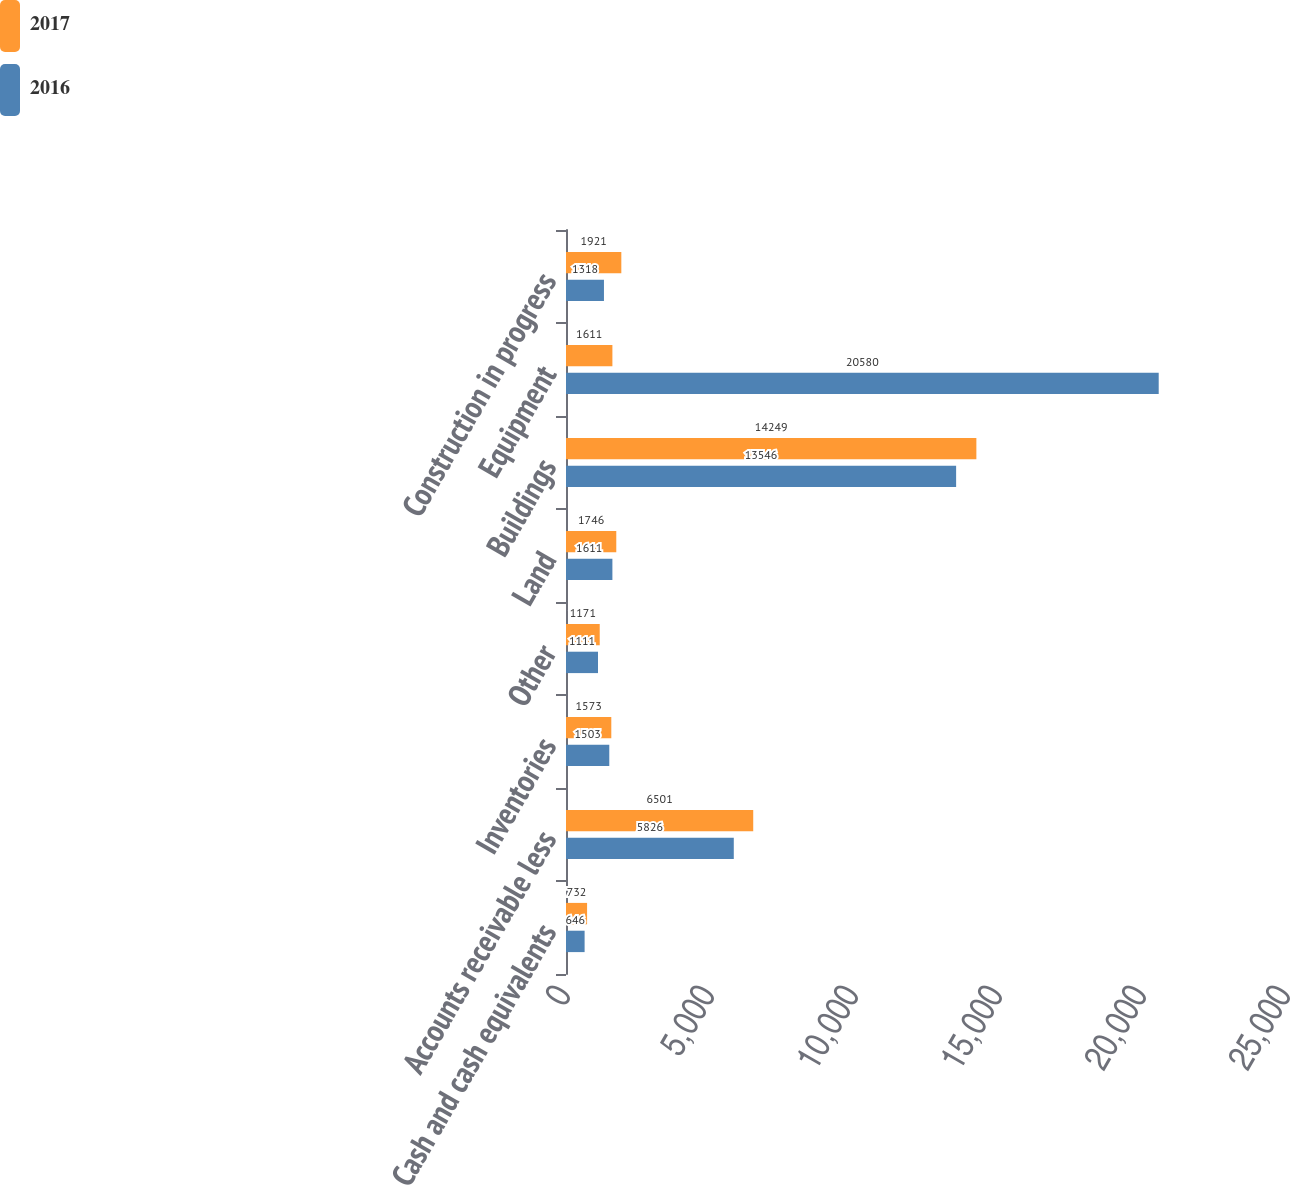<chart> <loc_0><loc_0><loc_500><loc_500><stacked_bar_chart><ecel><fcel>Cash and cash equivalents<fcel>Accounts receivable less<fcel>Inventories<fcel>Other<fcel>Land<fcel>Buildings<fcel>Equipment<fcel>Construction in progress<nl><fcel>2017<fcel>732<fcel>6501<fcel>1573<fcel>1171<fcel>1746<fcel>14249<fcel>1611<fcel>1921<nl><fcel>2016<fcel>646<fcel>5826<fcel>1503<fcel>1111<fcel>1611<fcel>13546<fcel>20580<fcel>1318<nl></chart> 